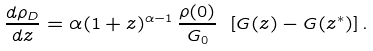<formula> <loc_0><loc_0><loc_500><loc_500>\frac { d \rho _ { D } } { d z } = \alpha ( 1 + z ) ^ { \alpha - 1 } \, \frac { \rho ( 0 ) } { G _ { 0 } } \ [ G ( z ) - G ( z ^ { * } ) ] \, .</formula> 